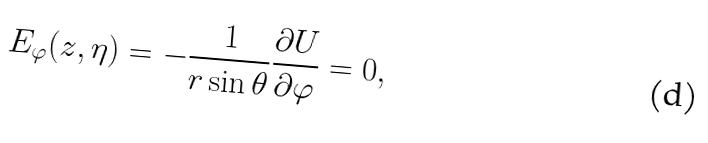Convert formula to latex. <formula><loc_0><loc_0><loc_500><loc_500>E _ { \varphi } ( z , \eta ) = - \frac { 1 } { r \sin \theta } \frac { \partial U } { \partial \varphi } = 0 ,</formula> 